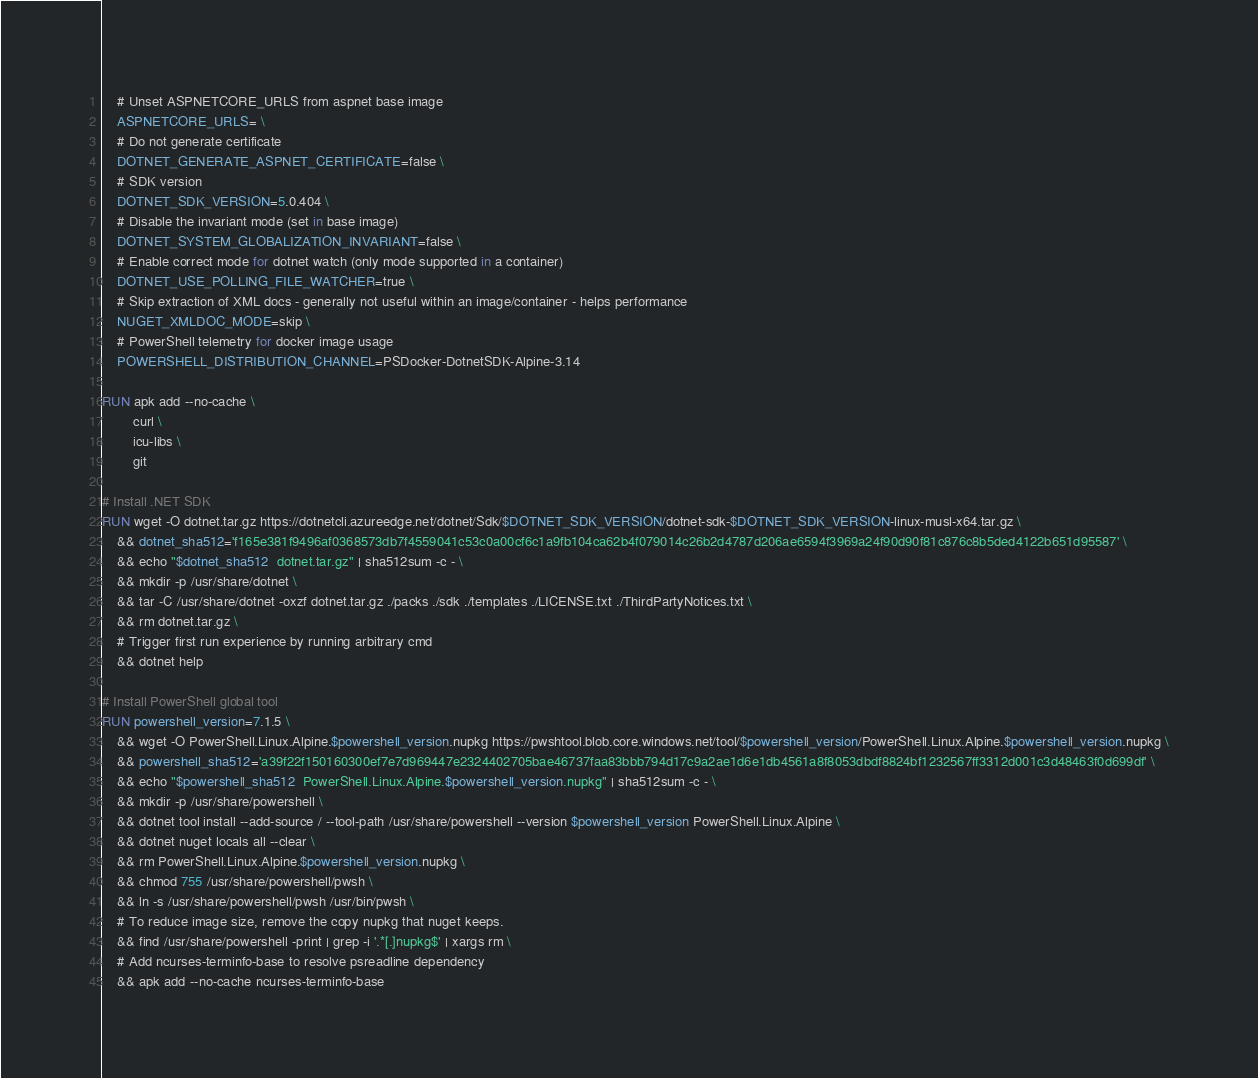<code> <loc_0><loc_0><loc_500><loc_500><_Dockerfile_>    # Unset ASPNETCORE_URLS from aspnet base image
    ASPNETCORE_URLS= \
    # Do not generate certificate
    DOTNET_GENERATE_ASPNET_CERTIFICATE=false \
    # SDK version
    DOTNET_SDK_VERSION=5.0.404 \
    # Disable the invariant mode (set in base image)
    DOTNET_SYSTEM_GLOBALIZATION_INVARIANT=false \
    # Enable correct mode for dotnet watch (only mode supported in a container)
    DOTNET_USE_POLLING_FILE_WATCHER=true \
    # Skip extraction of XML docs - generally not useful within an image/container - helps performance
    NUGET_XMLDOC_MODE=skip \
    # PowerShell telemetry for docker image usage
    POWERSHELL_DISTRIBUTION_CHANNEL=PSDocker-DotnetSDK-Alpine-3.14

RUN apk add --no-cache \
        curl \
        icu-libs \
        git

# Install .NET SDK
RUN wget -O dotnet.tar.gz https://dotnetcli.azureedge.net/dotnet/Sdk/$DOTNET_SDK_VERSION/dotnet-sdk-$DOTNET_SDK_VERSION-linux-musl-x64.tar.gz \
    && dotnet_sha512='f165e381f9496af0368573db7f4559041c53c0a00cf6c1a9fb104ca62b4f079014c26b2d4787d206ae6594f3969a24f90d90f81c876c8b5ded4122b651d95587' \
    && echo "$dotnet_sha512  dotnet.tar.gz" | sha512sum -c - \
    && mkdir -p /usr/share/dotnet \
    && tar -C /usr/share/dotnet -oxzf dotnet.tar.gz ./packs ./sdk ./templates ./LICENSE.txt ./ThirdPartyNotices.txt \
    && rm dotnet.tar.gz \
    # Trigger first run experience by running arbitrary cmd
    && dotnet help

# Install PowerShell global tool
RUN powershell_version=7.1.5 \
    && wget -O PowerShell.Linux.Alpine.$powershell_version.nupkg https://pwshtool.blob.core.windows.net/tool/$powershell_version/PowerShell.Linux.Alpine.$powershell_version.nupkg \
    && powershell_sha512='a39f22f150160300ef7e7d969447e2324402705bae46737faa83bbb794d17c9a2ae1d6e1db4561a8f8053dbdf8824bf1232567ff3312d001c3d48463f0d699df' \
    && echo "$powershell_sha512  PowerShell.Linux.Alpine.$powershell_version.nupkg" | sha512sum -c - \
    && mkdir -p /usr/share/powershell \
    && dotnet tool install --add-source / --tool-path /usr/share/powershell --version $powershell_version PowerShell.Linux.Alpine \
    && dotnet nuget locals all --clear \
    && rm PowerShell.Linux.Alpine.$powershell_version.nupkg \
    && chmod 755 /usr/share/powershell/pwsh \
    && ln -s /usr/share/powershell/pwsh /usr/bin/pwsh \
    # To reduce image size, remove the copy nupkg that nuget keeps.
    && find /usr/share/powershell -print | grep -i '.*[.]nupkg$' | xargs rm \
    # Add ncurses-terminfo-base to resolve psreadline dependency
    && apk add --no-cache ncurses-terminfo-base
</code> 